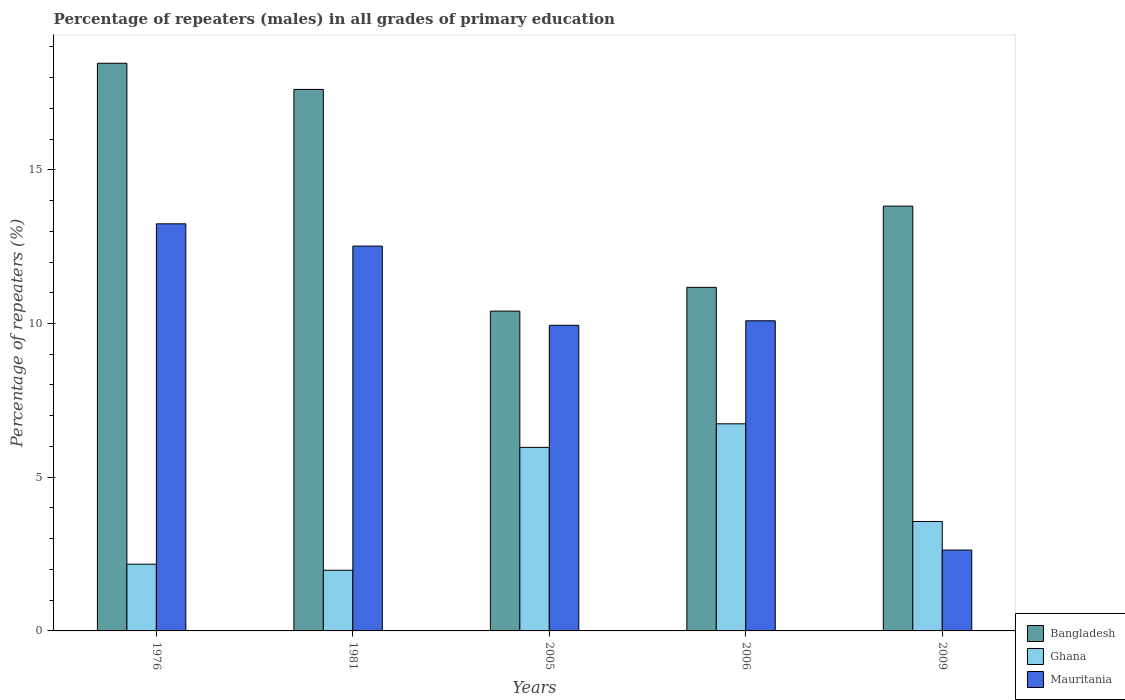How many groups of bars are there?
Provide a succinct answer. 5. Are the number of bars on each tick of the X-axis equal?
Your answer should be compact. Yes. How many bars are there on the 3rd tick from the left?
Your answer should be very brief. 3. In how many cases, is the number of bars for a given year not equal to the number of legend labels?
Offer a terse response. 0. What is the percentage of repeaters (males) in Ghana in 2006?
Offer a terse response. 6.74. Across all years, what is the maximum percentage of repeaters (males) in Ghana?
Your answer should be compact. 6.74. Across all years, what is the minimum percentage of repeaters (males) in Mauritania?
Give a very brief answer. 2.63. In which year was the percentage of repeaters (males) in Mauritania maximum?
Your response must be concise. 1976. What is the total percentage of repeaters (males) in Bangladesh in the graph?
Your answer should be compact. 71.48. What is the difference between the percentage of repeaters (males) in Ghana in 1976 and that in 1981?
Make the answer very short. 0.2. What is the difference between the percentage of repeaters (males) in Mauritania in 2005 and the percentage of repeaters (males) in Ghana in 2006?
Your response must be concise. 3.21. What is the average percentage of repeaters (males) in Mauritania per year?
Your answer should be compact. 9.68. In the year 1981, what is the difference between the percentage of repeaters (males) in Mauritania and percentage of repeaters (males) in Bangladesh?
Make the answer very short. -5.1. What is the ratio of the percentage of repeaters (males) in Bangladesh in 2005 to that in 2006?
Offer a terse response. 0.93. What is the difference between the highest and the second highest percentage of repeaters (males) in Ghana?
Your answer should be very brief. 0.77. What is the difference between the highest and the lowest percentage of repeaters (males) in Bangladesh?
Provide a succinct answer. 8.06. In how many years, is the percentage of repeaters (males) in Ghana greater than the average percentage of repeaters (males) in Ghana taken over all years?
Your answer should be compact. 2. Is it the case that in every year, the sum of the percentage of repeaters (males) in Ghana and percentage of repeaters (males) in Bangladesh is greater than the percentage of repeaters (males) in Mauritania?
Your answer should be compact. Yes. Are all the bars in the graph horizontal?
Provide a short and direct response. No. Are the values on the major ticks of Y-axis written in scientific E-notation?
Make the answer very short. No. Does the graph contain grids?
Make the answer very short. No. Where does the legend appear in the graph?
Give a very brief answer. Bottom right. How many legend labels are there?
Provide a short and direct response. 3. What is the title of the graph?
Your answer should be very brief. Percentage of repeaters (males) in all grades of primary education. What is the label or title of the Y-axis?
Keep it short and to the point. Percentage of repeaters (%). What is the Percentage of repeaters (%) of Bangladesh in 1976?
Provide a short and direct response. 18.47. What is the Percentage of repeaters (%) in Ghana in 1976?
Your answer should be compact. 2.17. What is the Percentage of repeaters (%) in Mauritania in 1976?
Provide a succinct answer. 13.24. What is the Percentage of repeaters (%) of Bangladesh in 1981?
Provide a short and direct response. 17.61. What is the Percentage of repeaters (%) of Ghana in 1981?
Keep it short and to the point. 1.97. What is the Percentage of repeaters (%) of Mauritania in 1981?
Your answer should be compact. 12.52. What is the Percentage of repeaters (%) in Bangladesh in 2005?
Your answer should be very brief. 10.4. What is the Percentage of repeaters (%) in Ghana in 2005?
Ensure brevity in your answer.  5.97. What is the Percentage of repeaters (%) in Mauritania in 2005?
Your answer should be compact. 9.94. What is the Percentage of repeaters (%) of Bangladesh in 2006?
Provide a succinct answer. 11.18. What is the Percentage of repeaters (%) of Ghana in 2006?
Give a very brief answer. 6.74. What is the Percentage of repeaters (%) of Mauritania in 2006?
Keep it short and to the point. 10.09. What is the Percentage of repeaters (%) of Bangladesh in 2009?
Ensure brevity in your answer.  13.82. What is the Percentage of repeaters (%) in Ghana in 2009?
Offer a terse response. 3.56. What is the Percentage of repeaters (%) in Mauritania in 2009?
Make the answer very short. 2.63. Across all years, what is the maximum Percentage of repeaters (%) in Bangladesh?
Provide a succinct answer. 18.47. Across all years, what is the maximum Percentage of repeaters (%) in Ghana?
Keep it short and to the point. 6.74. Across all years, what is the maximum Percentage of repeaters (%) in Mauritania?
Offer a terse response. 13.24. Across all years, what is the minimum Percentage of repeaters (%) of Bangladesh?
Ensure brevity in your answer.  10.4. Across all years, what is the minimum Percentage of repeaters (%) of Ghana?
Ensure brevity in your answer.  1.97. Across all years, what is the minimum Percentage of repeaters (%) in Mauritania?
Provide a short and direct response. 2.63. What is the total Percentage of repeaters (%) of Bangladesh in the graph?
Offer a very short reply. 71.48. What is the total Percentage of repeaters (%) in Ghana in the graph?
Offer a terse response. 20.41. What is the total Percentage of repeaters (%) in Mauritania in the graph?
Make the answer very short. 48.42. What is the difference between the Percentage of repeaters (%) in Bangladesh in 1976 and that in 1981?
Provide a succinct answer. 0.85. What is the difference between the Percentage of repeaters (%) in Ghana in 1976 and that in 1981?
Give a very brief answer. 0.2. What is the difference between the Percentage of repeaters (%) in Mauritania in 1976 and that in 1981?
Ensure brevity in your answer.  0.72. What is the difference between the Percentage of repeaters (%) of Bangladesh in 1976 and that in 2005?
Your answer should be compact. 8.06. What is the difference between the Percentage of repeaters (%) in Ghana in 1976 and that in 2005?
Your answer should be compact. -3.8. What is the difference between the Percentage of repeaters (%) of Mauritania in 1976 and that in 2005?
Provide a succinct answer. 3.3. What is the difference between the Percentage of repeaters (%) in Bangladesh in 1976 and that in 2006?
Offer a very short reply. 7.29. What is the difference between the Percentage of repeaters (%) in Ghana in 1976 and that in 2006?
Offer a terse response. -4.57. What is the difference between the Percentage of repeaters (%) in Mauritania in 1976 and that in 2006?
Ensure brevity in your answer.  3.15. What is the difference between the Percentage of repeaters (%) in Bangladesh in 1976 and that in 2009?
Provide a succinct answer. 4.65. What is the difference between the Percentage of repeaters (%) of Ghana in 1976 and that in 2009?
Offer a very short reply. -1.39. What is the difference between the Percentage of repeaters (%) of Mauritania in 1976 and that in 2009?
Ensure brevity in your answer.  10.61. What is the difference between the Percentage of repeaters (%) of Bangladesh in 1981 and that in 2005?
Your answer should be very brief. 7.21. What is the difference between the Percentage of repeaters (%) of Ghana in 1981 and that in 2005?
Your answer should be very brief. -4. What is the difference between the Percentage of repeaters (%) of Mauritania in 1981 and that in 2005?
Make the answer very short. 2.58. What is the difference between the Percentage of repeaters (%) of Bangladesh in 1981 and that in 2006?
Your response must be concise. 6.44. What is the difference between the Percentage of repeaters (%) of Ghana in 1981 and that in 2006?
Your answer should be very brief. -4.76. What is the difference between the Percentage of repeaters (%) in Mauritania in 1981 and that in 2006?
Offer a terse response. 2.43. What is the difference between the Percentage of repeaters (%) in Bangladesh in 1981 and that in 2009?
Your response must be concise. 3.8. What is the difference between the Percentage of repeaters (%) in Ghana in 1981 and that in 2009?
Your answer should be very brief. -1.59. What is the difference between the Percentage of repeaters (%) in Mauritania in 1981 and that in 2009?
Your answer should be very brief. 9.89. What is the difference between the Percentage of repeaters (%) of Bangladesh in 2005 and that in 2006?
Offer a very short reply. -0.77. What is the difference between the Percentage of repeaters (%) in Ghana in 2005 and that in 2006?
Make the answer very short. -0.77. What is the difference between the Percentage of repeaters (%) in Mauritania in 2005 and that in 2006?
Your answer should be compact. -0.15. What is the difference between the Percentage of repeaters (%) in Bangladesh in 2005 and that in 2009?
Make the answer very short. -3.41. What is the difference between the Percentage of repeaters (%) in Ghana in 2005 and that in 2009?
Your answer should be compact. 2.41. What is the difference between the Percentage of repeaters (%) of Mauritania in 2005 and that in 2009?
Provide a short and direct response. 7.31. What is the difference between the Percentage of repeaters (%) of Bangladesh in 2006 and that in 2009?
Your response must be concise. -2.64. What is the difference between the Percentage of repeaters (%) in Ghana in 2006 and that in 2009?
Your response must be concise. 3.18. What is the difference between the Percentage of repeaters (%) of Mauritania in 2006 and that in 2009?
Your response must be concise. 7.46. What is the difference between the Percentage of repeaters (%) of Bangladesh in 1976 and the Percentage of repeaters (%) of Ghana in 1981?
Keep it short and to the point. 16.49. What is the difference between the Percentage of repeaters (%) of Bangladesh in 1976 and the Percentage of repeaters (%) of Mauritania in 1981?
Your answer should be very brief. 5.95. What is the difference between the Percentage of repeaters (%) in Ghana in 1976 and the Percentage of repeaters (%) in Mauritania in 1981?
Your response must be concise. -10.35. What is the difference between the Percentage of repeaters (%) of Bangladesh in 1976 and the Percentage of repeaters (%) of Ghana in 2005?
Your answer should be compact. 12.49. What is the difference between the Percentage of repeaters (%) of Bangladesh in 1976 and the Percentage of repeaters (%) of Mauritania in 2005?
Offer a terse response. 8.52. What is the difference between the Percentage of repeaters (%) in Ghana in 1976 and the Percentage of repeaters (%) in Mauritania in 2005?
Offer a very short reply. -7.77. What is the difference between the Percentage of repeaters (%) of Bangladesh in 1976 and the Percentage of repeaters (%) of Ghana in 2006?
Keep it short and to the point. 11.73. What is the difference between the Percentage of repeaters (%) in Bangladesh in 1976 and the Percentage of repeaters (%) in Mauritania in 2006?
Provide a succinct answer. 8.38. What is the difference between the Percentage of repeaters (%) of Ghana in 1976 and the Percentage of repeaters (%) of Mauritania in 2006?
Provide a short and direct response. -7.92. What is the difference between the Percentage of repeaters (%) in Bangladesh in 1976 and the Percentage of repeaters (%) in Ghana in 2009?
Ensure brevity in your answer.  14.91. What is the difference between the Percentage of repeaters (%) of Bangladesh in 1976 and the Percentage of repeaters (%) of Mauritania in 2009?
Give a very brief answer. 15.83. What is the difference between the Percentage of repeaters (%) of Ghana in 1976 and the Percentage of repeaters (%) of Mauritania in 2009?
Provide a succinct answer. -0.46. What is the difference between the Percentage of repeaters (%) in Bangladesh in 1981 and the Percentage of repeaters (%) in Ghana in 2005?
Your answer should be very brief. 11.64. What is the difference between the Percentage of repeaters (%) of Bangladesh in 1981 and the Percentage of repeaters (%) of Mauritania in 2005?
Keep it short and to the point. 7.67. What is the difference between the Percentage of repeaters (%) of Ghana in 1981 and the Percentage of repeaters (%) of Mauritania in 2005?
Make the answer very short. -7.97. What is the difference between the Percentage of repeaters (%) of Bangladesh in 1981 and the Percentage of repeaters (%) of Ghana in 2006?
Ensure brevity in your answer.  10.88. What is the difference between the Percentage of repeaters (%) in Bangladesh in 1981 and the Percentage of repeaters (%) in Mauritania in 2006?
Your answer should be compact. 7.53. What is the difference between the Percentage of repeaters (%) in Ghana in 1981 and the Percentage of repeaters (%) in Mauritania in 2006?
Provide a succinct answer. -8.12. What is the difference between the Percentage of repeaters (%) of Bangladesh in 1981 and the Percentage of repeaters (%) of Ghana in 2009?
Offer a terse response. 14.05. What is the difference between the Percentage of repeaters (%) in Bangladesh in 1981 and the Percentage of repeaters (%) in Mauritania in 2009?
Your answer should be compact. 14.98. What is the difference between the Percentage of repeaters (%) in Ghana in 1981 and the Percentage of repeaters (%) in Mauritania in 2009?
Keep it short and to the point. -0.66. What is the difference between the Percentage of repeaters (%) in Bangladesh in 2005 and the Percentage of repeaters (%) in Ghana in 2006?
Offer a terse response. 3.67. What is the difference between the Percentage of repeaters (%) in Bangladesh in 2005 and the Percentage of repeaters (%) in Mauritania in 2006?
Your response must be concise. 0.31. What is the difference between the Percentage of repeaters (%) in Ghana in 2005 and the Percentage of repeaters (%) in Mauritania in 2006?
Provide a succinct answer. -4.12. What is the difference between the Percentage of repeaters (%) in Bangladesh in 2005 and the Percentage of repeaters (%) in Ghana in 2009?
Offer a terse response. 6.84. What is the difference between the Percentage of repeaters (%) in Bangladesh in 2005 and the Percentage of repeaters (%) in Mauritania in 2009?
Provide a succinct answer. 7.77. What is the difference between the Percentage of repeaters (%) in Ghana in 2005 and the Percentage of repeaters (%) in Mauritania in 2009?
Give a very brief answer. 3.34. What is the difference between the Percentage of repeaters (%) in Bangladesh in 2006 and the Percentage of repeaters (%) in Ghana in 2009?
Offer a very short reply. 7.62. What is the difference between the Percentage of repeaters (%) in Bangladesh in 2006 and the Percentage of repeaters (%) in Mauritania in 2009?
Your answer should be very brief. 8.54. What is the difference between the Percentage of repeaters (%) of Ghana in 2006 and the Percentage of repeaters (%) of Mauritania in 2009?
Provide a short and direct response. 4.11. What is the average Percentage of repeaters (%) in Bangladesh per year?
Your response must be concise. 14.3. What is the average Percentage of repeaters (%) in Ghana per year?
Your answer should be compact. 4.08. What is the average Percentage of repeaters (%) in Mauritania per year?
Give a very brief answer. 9.68. In the year 1976, what is the difference between the Percentage of repeaters (%) in Bangladesh and Percentage of repeaters (%) in Ghana?
Provide a succinct answer. 16.29. In the year 1976, what is the difference between the Percentage of repeaters (%) of Bangladesh and Percentage of repeaters (%) of Mauritania?
Offer a terse response. 5.22. In the year 1976, what is the difference between the Percentage of repeaters (%) of Ghana and Percentage of repeaters (%) of Mauritania?
Provide a short and direct response. -11.07. In the year 1981, what is the difference between the Percentage of repeaters (%) in Bangladesh and Percentage of repeaters (%) in Ghana?
Your answer should be compact. 15.64. In the year 1981, what is the difference between the Percentage of repeaters (%) in Bangladesh and Percentage of repeaters (%) in Mauritania?
Make the answer very short. 5.1. In the year 1981, what is the difference between the Percentage of repeaters (%) in Ghana and Percentage of repeaters (%) in Mauritania?
Ensure brevity in your answer.  -10.55. In the year 2005, what is the difference between the Percentage of repeaters (%) in Bangladesh and Percentage of repeaters (%) in Ghana?
Your answer should be very brief. 4.43. In the year 2005, what is the difference between the Percentage of repeaters (%) in Bangladesh and Percentage of repeaters (%) in Mauritania?
Offer a terse response. 0.46. In the year 2005, what is the difference between the Percentage of repeaters (%) in Ghana and Percentage of repeaters (%) in Mauritania?
Ensure brevity in your answer.  -3.97. In the year 2006, what is the difference between the Percentage of repeaters (%) in Bangladesh and Percentage of repeaters (%) in Ghana?
Your answer should be very brief. 4.44. In the year 2006, what is the difference between the Percentage of repeaters (%) of Bangladesh and Percentage of repeaters (%) of Mauritania?
Keep it short and to the point. 1.09. In the year 2006, what is the difference between the Percentage of repeaters (%) in Ghana and Percentage of repeaters (%) in Mauritania?
Make the answer very short. -3.35. In the year 2009, what is the difference between the Percentage of repeaters (%) of Bangladesh and Percentage of repeaters (%) of Ghana?
Give a very brief answer. 10.26. In the year 2009, what is the difference between the Percentage of repeaters (%) in Bangladesh and Percentage of repeaters (%) in Mauritania?
Ensure brevity in your answer.  11.19. In the year 2009, what is the difference between the Percentage of repeaters (%) in Ghana and Percentage of repeaters (%) in Mauritania?
Your answer should be very brief. 0.93. What is the ratio of the Percentage of repeaters (%) of Bangladesh in 1976 to that in 1981?
Make the answer very short. 1.05. What is the ratio of the Percentage of repeaters (%) in Ghana in 1976 to that in 1981?
Your response must be concise. 1.1. What is the ratio of the Percentage of repeaters (%) of Mauritania in 1976 to that in 1981?
Your answer should be compact. 1.06. What is the ratio of the Percentage of repeaters (%) of Bangladesh in 1976 to that in 2005?
Your answer should be very brief. 1.77. What is the ratio of the Percentage of repeaters (%) in Ghana in 1976 to that in 2005?
Your answer should be compact. 0.36. What is the ratio of the Percentage of repeaters (%) of Mauritania in 1976 to that in 2005?
Make the answer very short. 1.33. What is the ratio of the Percentage of repeaters (%) of Bangladesh in 1976 to that in 2006?
Your answer should be compact. 1.65. What is the ratio of the Percentage of repeaters (%) of Ghana in 1976 to that in 2006?
Offer a very short reply. 0.32. What is the ratio of the Percentage of repeaters (%) in Mauritania in 1976 to that in 2006?
Your answer should be compact. 1.31. What is the ratio of the Percentage of repeaters (%) of Bangladesh in 1976 to that in 2009?
Make the answer very short. 1.34. What is the ratio of the Percentage of repeaters (%) of Ghana in 1976 to that in 2009?
Offer a very short reply. 0.61. What is the ratio of the Percentage of repeaters (%) in Mauritania in 1976 to that in 2009?
Offer a terse response. 5.03. What is the ratio of the Percentage of repeaters (%) of Bangladesh in 1981 to that in 2005?
Your answer should be very brief. 1.69. What is the ratio of the Percentage of repeaters (%) in Ghana in 1981 to that in 2005?
Ensure brevity in your answer.  0.33. What is the ratio of the Percentage of repeaters (%) in Mauritania in 1981 to that in 2005?
Your answer should be compact. 1.26. What is the ratio of the Percentage of repeaters (%) in Bangladesh in 1981 to that in 2006?
Provide a succinct answer. 1.58. What is the ratio of the Percentage of repeaters (%) of Ghana in 1981 to that in 2006?
Make the answer very short. 0.29. What is the ratio of the Percentage of repeaters (%) of Mauritania in 1981 to that in 2006?
Give a very brief answer. 1.24. What is the ratio of the Percentage of repeaters (%) of Bangladesh in 1981 to that in 2009?
Provide a succinct answer. 1.27. What is the ratio of the Percentage of repeaters (%) in Ghana in 1981 to that in 2009?
Provide a short and direct response. 0.55. What is the ratio of the Percentage of repeaters (%) in Mauritania in 1981 to that in 2009?
Offer a terse response. 4.76. What is the ratio of the Percentage of repeaters (%) in Bangladesh in 2005 to that in 2006?
Your response must be concise. 0.93. What is the ratio of the Percentage of repeaters (%) of Ghana in 2005 to that in 2006?
Offer a terse response. 0.89. What is the ratio of the Percentage of repeaters (%) of Mauritania in 2005 to that in 2006?
Provide a short and direct response. 0.99. What is the ratio of the Percentage of repeaters (%) in Bangladesh in 2005 to that in 2009?
Provide a succinct answer. 0.75. What is the ratio of the Percentage of repeaters (%) in Ghana in 2005 to that in 2009?
Offer a very short reply. 1.68. What is the ratio of the Percentage of repeaters (%) of Mauritania in 2005 to that in 2009?
Provide a short and direct response. 3.78. What is the ratio of the Percentage of repeaters (%) in Bangladesh in 2006 to that in 2009?
Offer a terse response. 0.81. What is the ratio of the Percentage of repeaters (%) of Ghana in 2006 to that in 2009?
Ensure brevity in your answer.  1.89. What is the ratio of the Percentage of repeaters (%) in Mauritania in 2006 to that in 2009?
Provide a short and direct response. 3.84. What is the difference between the highest and the second highest Percentage of repeaters (%) of Bangladesh?
Offer a terse response. 0.85. What is the difference between the highest and the second highest Percentage of repeaters (%) in Ghana?
Provide a succinct answer. 0.77. What is the difference between the highest and the second highest Percentage of repeaters (%) of Mauritania?
Offer a very short reply. 0.72. What is the difference between the highest and the lowest Percentage of repeaters (%) of Bangladesh?
Provide a succinct answer. 8.06. What is the difference between the highest and the lowest Percentage of repeaters (%) of Ghana?
Provide a succinct answer. 4.76. What is the difference between the highest and the lowest Percentage of repeaters (%) in Mauritania?
Your answer should be compact. 10.61. 